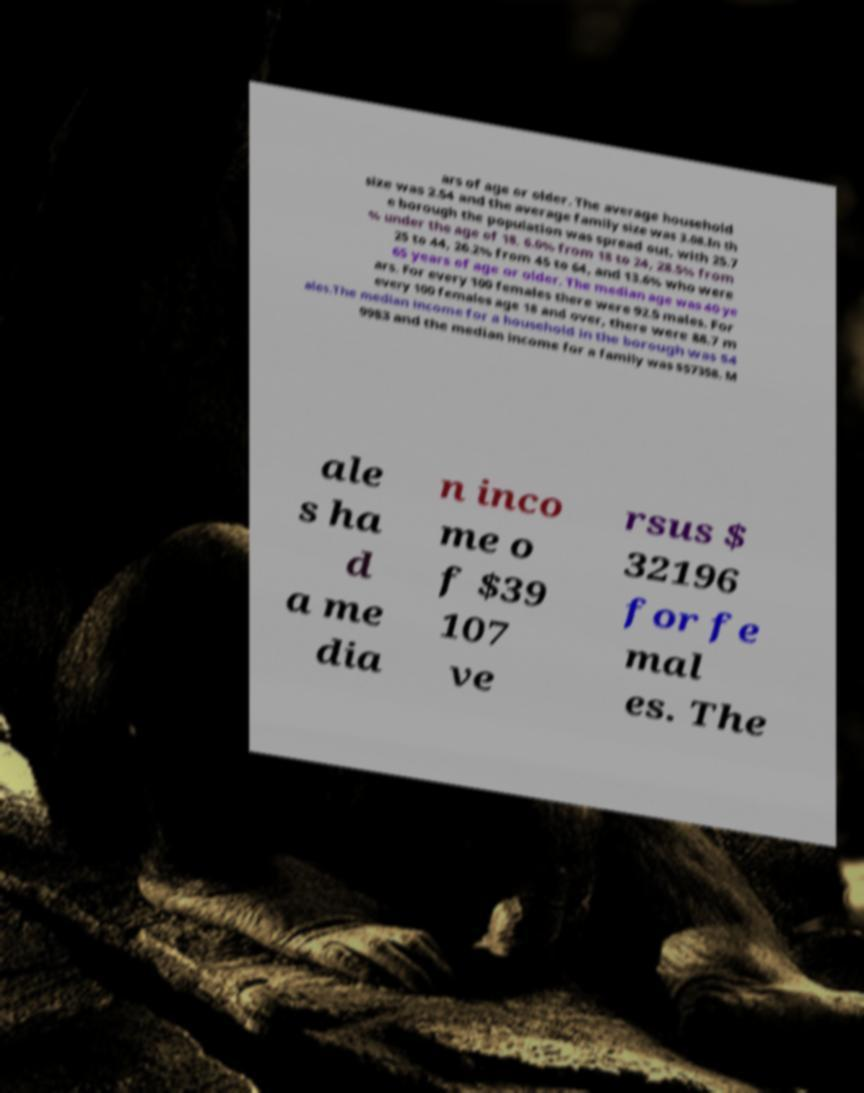Can you accurately transcribe the text from the provided image for me? ars of age or older. The average household size was 2.54 and the average family size was 3.08.In th e borough the population was spread out, with 25.7 % under the age of 18, 6.0% from 18 to 24, 28.5% from 25 to 44, 26.2% from 45 to 64, and 13.6% who were 65 years of age or older. The median age was 40 ye ars. For every 100 females there were 92.5 males. For every 100 females age 18 and over, there were 88.7 m ales.The median income for a household in the borough was $4 9983 and the median income for a family was $57358. M ale s ha d a me dia n inco me o f $39 107 ve rsus $ 32196 for fe mal es. The 